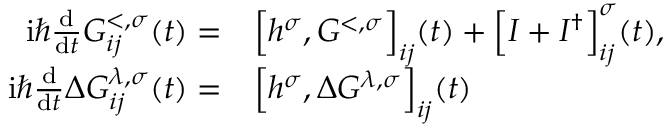Convert formula to latex. <formula><loc_0><loc_0><loc_500><loc_500>\begin{array} { r l } { i \hbar { } d } { d t } G _ { i j } ^ { < , \sigma } ( t ) = } & \left [ h ^ { \sigma } , G ^ { < , \sigma } \right ] _ { i j } ( t ) + \left [ I + I ^ { \dagger } \right ] _ { i j } ^ { \sigma } ( t ) , } \\ { i \hbar { } d } { d t } \Delta G _ { i j } ^ { \lambda , \sigma } ( t ) = } & \left [ h ^ { \sigma } , \Delta G ^ { \lambda , \sigma } \right ] _ { i j } ( t ) } \end{array}</formula> 